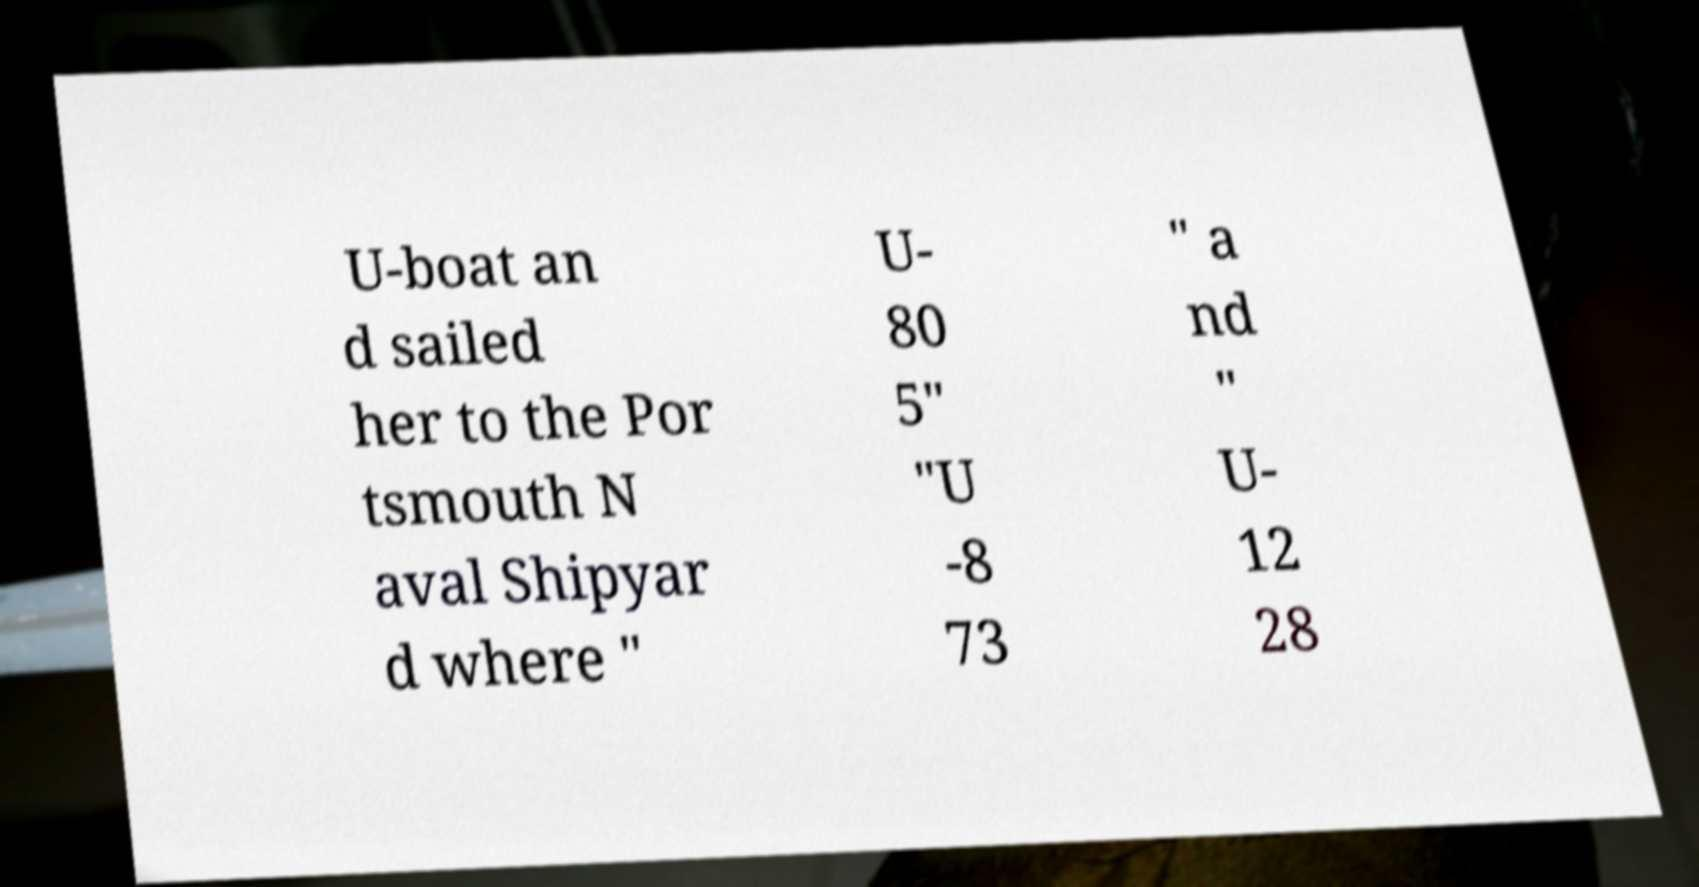Please identify and transcribe the text found in this image. U-boat an d sailed her to the Por tsmouth N aval Shipyar d where " U- 80 5" "U -8 73 " a nd " U- 12 28 